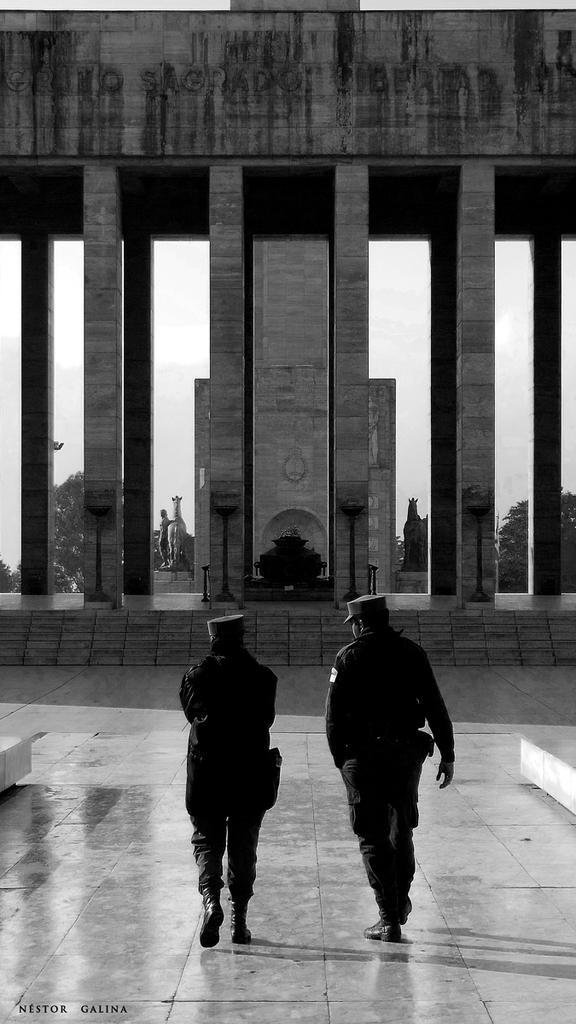Could you give a brief overview of what you see in this image? This image is a black and white image. This image is taken outdoors. At the bottom of the image there is a floor. At the top of the image there is a wall with a text on it. In the middle of the image two men are walking on the floor. There are a few pillars. In the background there is the sky with clouds and there are a few trees and there are a few sculptures. 